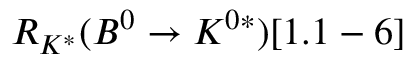<formula> <loc_0><loc_0><loc_500><loc_500>R _ { K ^ { * } } ( B ^ { 0 } \to K ^ { 0 * } ) [ 1 . 1 - 6 ]</formula> 